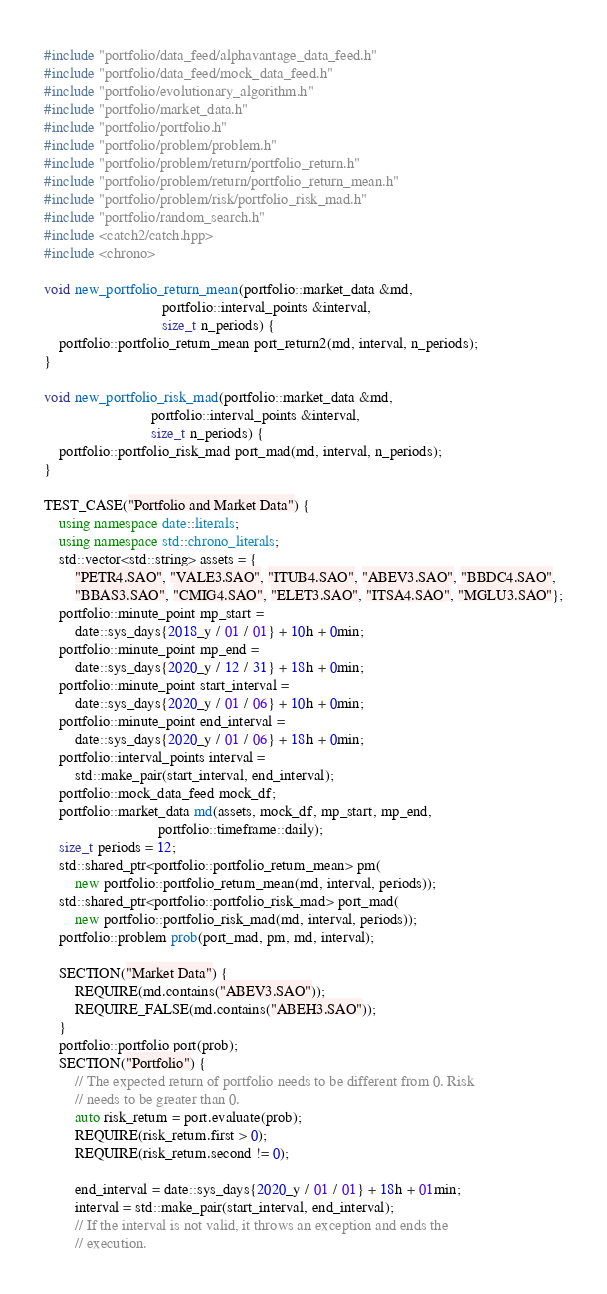Convert code to text. <code><loc_0><loc_0><loc_500><loc_500><_C++_>#include "portfolio/data_feed/alphavantage_data_feed.h"
#include "portfolio/data_feed/mock_data_feed.h"
#include "portfolio/evolutionary_algorithm.h"
#include "portfolio/market_data.h"
#include "portfolio/portfolio.h"
#include "portfolio/problem/problem.h"
#include "portfolio/problem/return/portfolio_return.h"
#include "portfolio/problem/return/portfolio_return_mean.h"
#include "portfolio/problem/risk/portfolio_risk_mad.h"
#include "portfolio/random_search.h"
#include <catch2/catch.hpp>
#include <chrono>

void new_portfolio_return_mean(portfolio::market_data &md,
                               portfolio::interval_points &interval,
                               size_t n_periods) {
    portfolio::portfolio_return_mean port_return2(md, interval, n_periods);
}

void new_portfolio_risk_mad(portfolio::market_data &md,
                            portfolio::interval_points &interval,
                            size_t n_periods) {
    portfolio::portfolio_risk_mad port_mad(md, interval, n_periods);
}

TEST_CASE("Portfolio and Market Data") {
    using namespace date::literals;
    using namespace std::chrono_literals;
    std::vector<std::string> assets = {
        "PETR4.SAO", "VALE3.SAO", "ITUB4.SAO", "ABEV3.SAO", "BBDC4.SAO",
        "BBAS3.SAO", "CMIG4.SAO", "ELET3.SAO", "ITSA4.SAO", "MGLU3.SAO"};
    portfolio::minute_point mp_start =
        date::sys_days{2018_y / 01 / 01} + 10h + 0min;
    portfolio::minute_point mp_end =
        date::sys_days{2020_y / 12 / 31} + 18h + 0min;
    portfolio::minute_point start_interval =
        date::sys_days{2020_y / 01 / 06} + 10h + 0min;
    portfolio::minute_point end_interval =
        date::sys_days{2020_y / 01 / 06} + 18h + 0min;
    portfolio::interval_points interval =
        std::make_pair(start_interval, end_interval);
    portfolio::mock_data_feed mock_df;
    portfolio::market_data md(assets, mock_df, mp_start, mp_end,
                              portfolio::timeframe::daily);
    size_t periods = 12;
    std::shared_ptr<portfolio::portfolio_return_mean> pm(
        new portfolio::portfolio_return_mean(md, interval, periods));
    std::shared_ptr<portfolio::portfolio_risk_mad> port_mad(
        new portfolio::portfolio_risk_mad(md, interval, periods));
    portfolio::problem prob(port_mad, pm, md, interval);

    SECTION("Market Data") {
        REQUIRE(md.contains("ABEV3.SAO"));
        REQUIRE_FALSE(md.contains("ABEH3.SAO"));
    }
    portfolio::portfolio port(prob);
    SECTION("Portfolio") {
        // The expected return of portfolio needs to be different from 0. Risk
        // needs to be greater than 0.
        auto risk_return = port.evaluate(prob);
        REQUIRE(risk_return.first > 0);
        REQUIRE(risk_return.second != 0);

        end_interval = date::sys_days{2020_y / 01 / 01} + 18h + 01min;
        interval = std::make_pair(start_interval, end_interval);
        // If the interval is not valid, it throws an exception and ends the
        // execution.</code> 